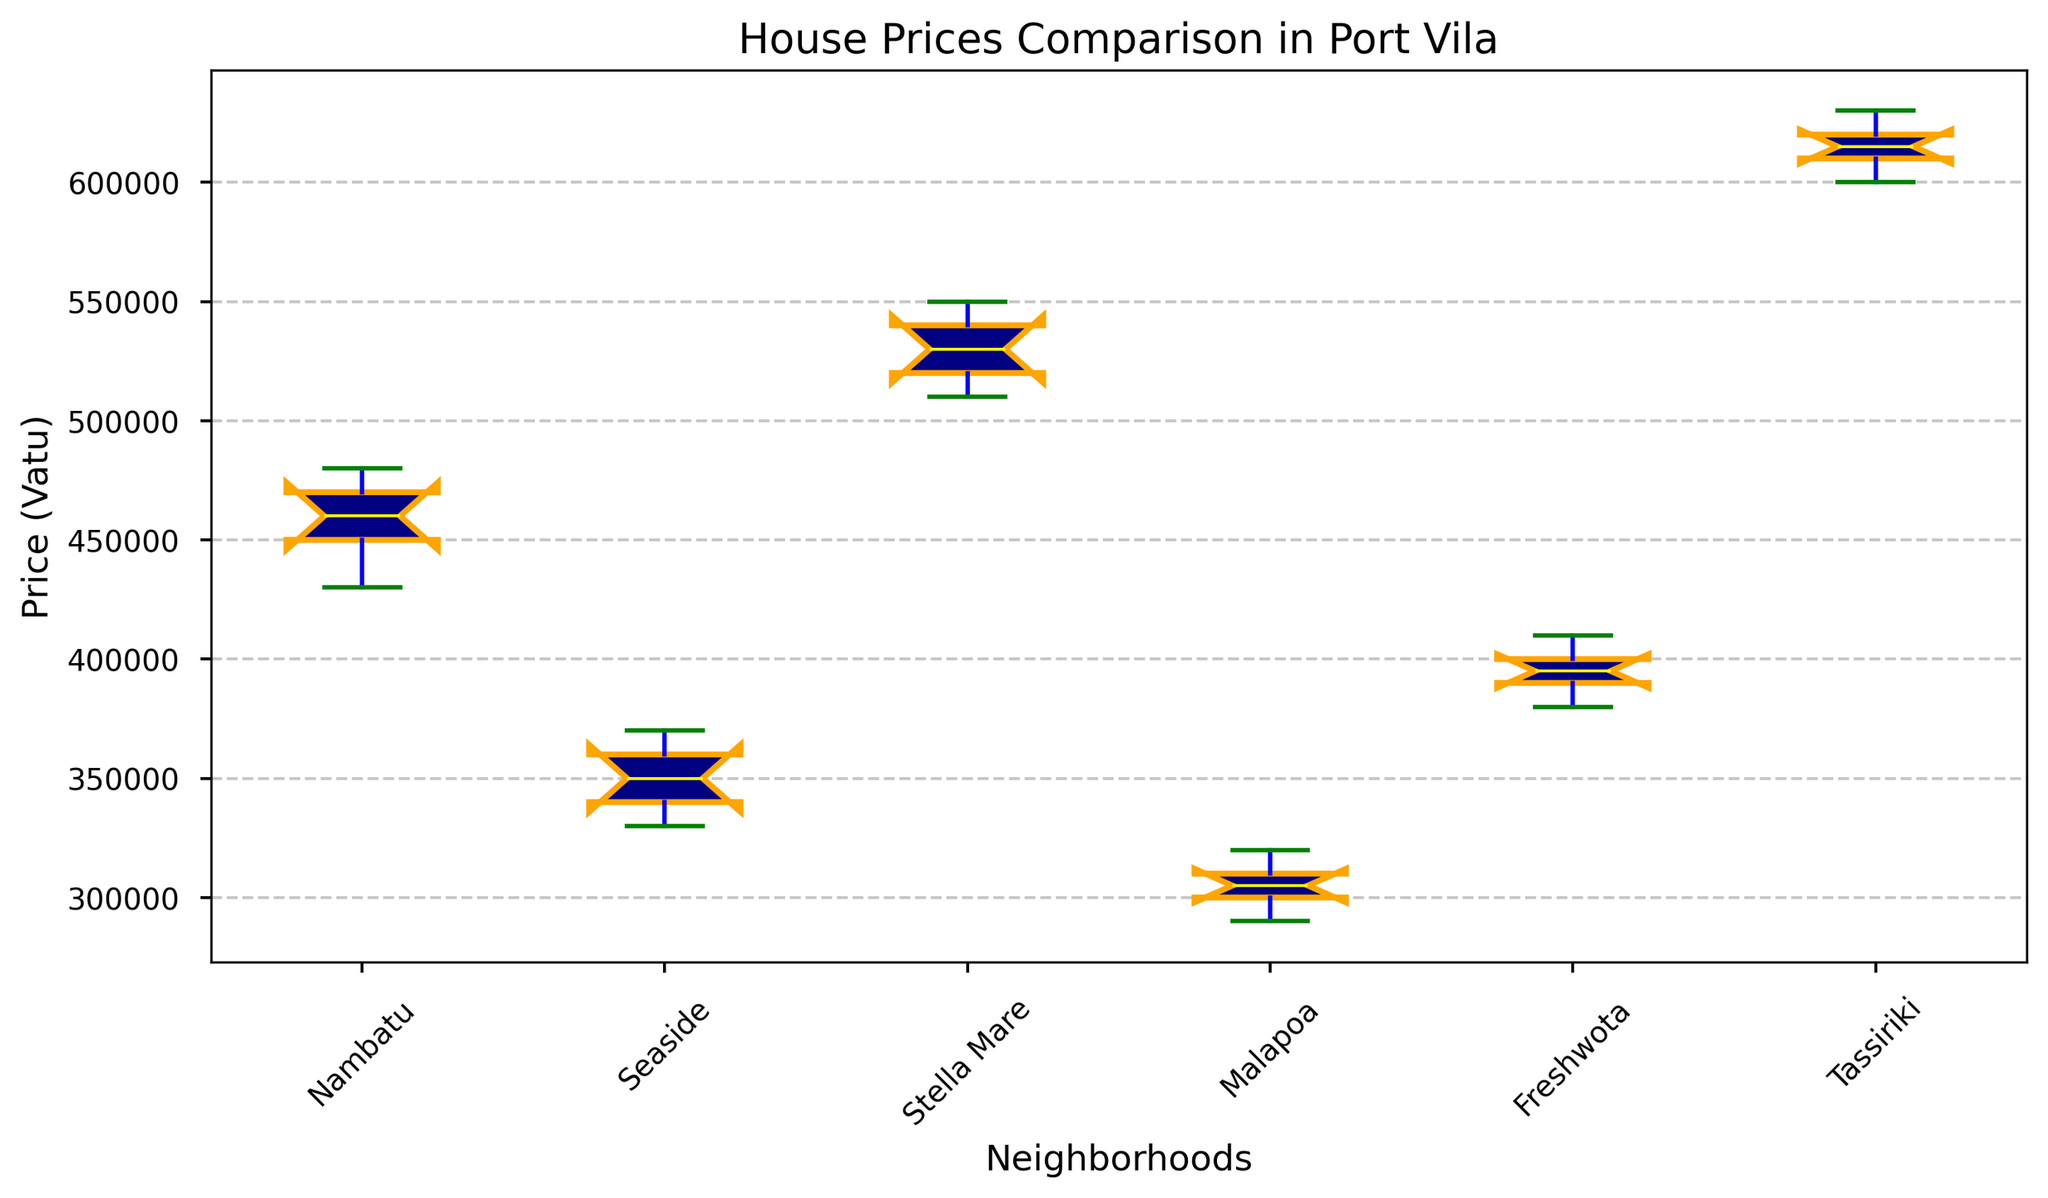Which neighborhood has the highest median house price? Find the horizontal line inside each box (the median line) and identify the neighborhood whose median line is the highest on the y-axis.
Answer: Tassiriki What is the range of house prices in Malapoa? Locate the top (maximum) and bottom (minimum) whiskers for Malapoa and calculate the difference between these two values.
Answer: 320,000 - 290,000 = 30,000 How does the median price in Nambatu compare to that in Freshwota? Compare the horizontal median lines inside the boxes for Nambatu and Freshwota by noting their positions along the y-axis. Nambatu's median line is above Freshwota's median line.
Answer: Nambatu's median is higher Which neighborhood has the widest range of house prices? Identify the neighborhood with the largest distance between the top and bottom whiskers.
Answer: Tassiriki Are there any neighborhoods with outliers? Look for red points outside the whiskers for any neighborhood. If there's no red point, there are no outliers.
Answer: No outliers What's the interquartile range (IQR) for Stella Mare? The IQR is the distance between the top and bottom of the box (the third quartile minus the first quartile).
Answer: 550,000 - 510,000 = 40,000 Which neighborhood's house prices have the least variability? Identify the neighborhood where the box, which represents the interquartile range, is the smallest.
Answer: Malapoa Is the median price of Nambatu greater than the maximum price of Seaside? Compare the horizontal median line in Nambatu with the top whisker (maximum price) in Seaside. The median line in Nambatu is above the top whisker in Seaside.
Answer: Yes How much higher is Tassiriki's median price compared to Seaside's median price? Find the difference in y-position between the horizontal median lines for Tassiriki and Seaside.
Answer: 610,000 - 350,000 = 260,000 Which neighborhood's house price whiskers show the greatest symmetry? Look for the box plot with the most equal length whiskers above and below the box.
Answer: Seaside 